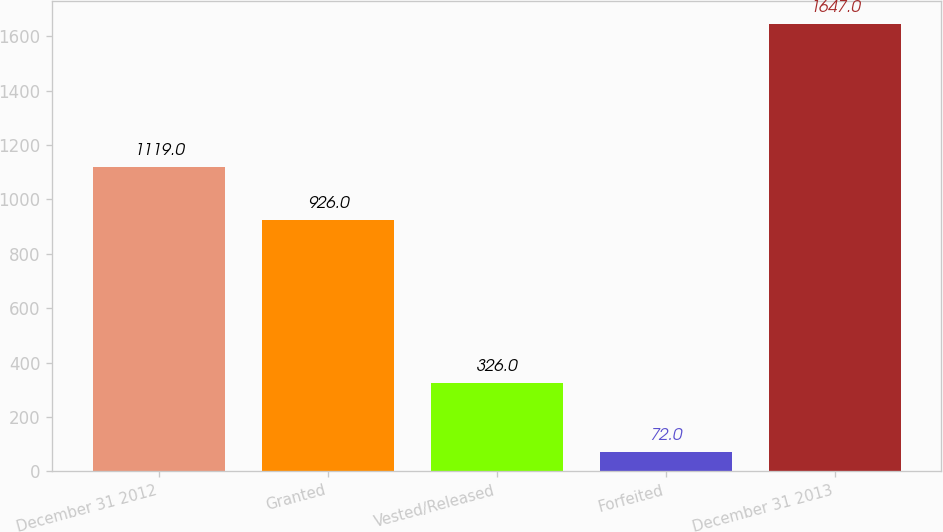Convert chart. <chart><loc_0><loc_0><loc_500><loc_500><bar_chart><fcel>December 31 2012<fcel>Granted<fcel>Vested/Released<fcel>Forfeited<fcel>December 31 2013<nl><fcel>1119<fcel>926<fcel>326<fcel>72<fcel>1647<nl></chart> 